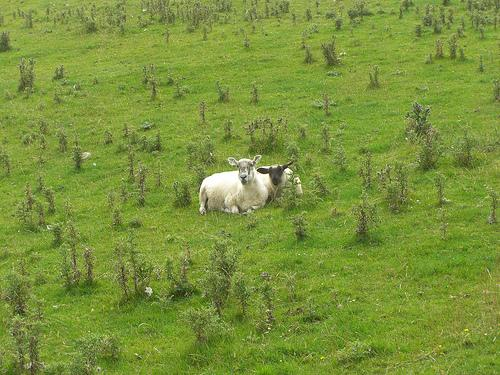What type of animals are the main subject in this image and what are they doing? White sheep are the main subject and they are resting on the grass. Identify the color and activity of the cows in the image. White cows are lying on green grass. List the features mentioned about the sheep in the picture. White, black face, lying down, looking at the camera, resting, ears, eyes, nose, back legs, front legs. How many sheep are there in the image and what colors are they? There are two sheep, one white and one black. What type of flowers can be seen in the image? Yellow flowers can be seen in the grass. In a few words, describe the interactions happening in the image. Two sheep are resting on grass, while white cows are lying nearby, and yellow flowers are scattered. What is the general sentiment conveyed by the image? The sentiment is peaceful and serene, as the animals are calmly resting on the grass. Identify the different object categories and their counts in the picture. Sheep: 2, Cows: 2, Long green and yellow grass: 15, Yellow flowers: 1. Explain the state and appearance of the grass in the image. The grass is green with weeds and has long green and yellow patches. Do the sheep in the image seem to be active or resting? The sheep are resting. Is the cow near the top right corner black? No, it's not mentioned in the image. What parts of the sheep's body can be seen in the image? ears, eyes, nose, front legs, back legs Describe the scene depicted in the image. Two white sheep and white cows are resting on green and yellow grass with yellow flowers. What is the overall setting of the pictured scene? a grassy hill What flowers can be seen among the grass? yellow flowers Choose the right caption for the animals in the image: A) White cows sitting on red carpet B) White cows lying on green grass C) Two black cows standing on a pavement B) White cows lying on green grass What is the most noticeable feature of the black sheep's face? its black color on white sheep's body What is the activity of the sheep and cows in the picture? resting or lying down Where are the yellow flowers located in the image? in the grass Are the sheep and cows standing or sitting in the scene? sitting What is the main action or event occurring in the image? sheep and cows resting in the grass In the image, what is the position of the long green and yellow grass relative to the white sheep and cows? Below and around them How many sheep appear in the scene, and can you describe their color? Two sheep, one white and one white with a black face What animals can be found in the image? sheep and cows Describe the appearance of the sheep in the image. One is white with a black face, and the other is all white. Write a sentence describing the image using the words "long green and yellow grass". Sheep and cows are resting on long green and yellow grass. What predominant colors can be found in the grass in the image? green and yellow Identify the color of the grass on which the animals are resting. green What is the position of the yellow flowers in relation to the white sheep? Below and to the right 